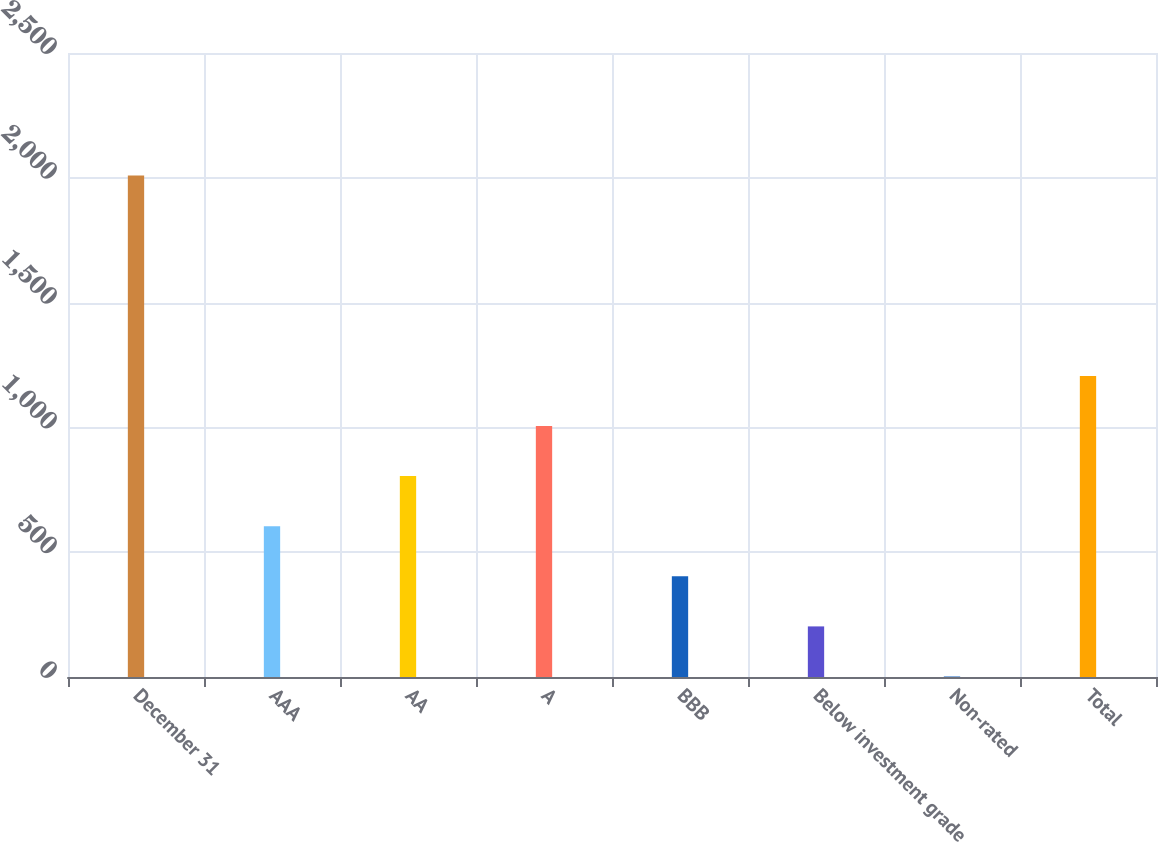<chart> <loc_0><loc_0><loc_500><loc_500><bar_chart><fcel>December 31<fcel>AAA<fcel>AA<fcel>A<fcel>BBB<fcel>Below investment grade<fcel>Non-rated<fcel>Total<nl><fcel>2009<fcel>604.1<fcel>804.8<fcel>1005.5<fcel>403.4<fcel>202.7<fcel>2<fcel>1206.2<nl></chart> 